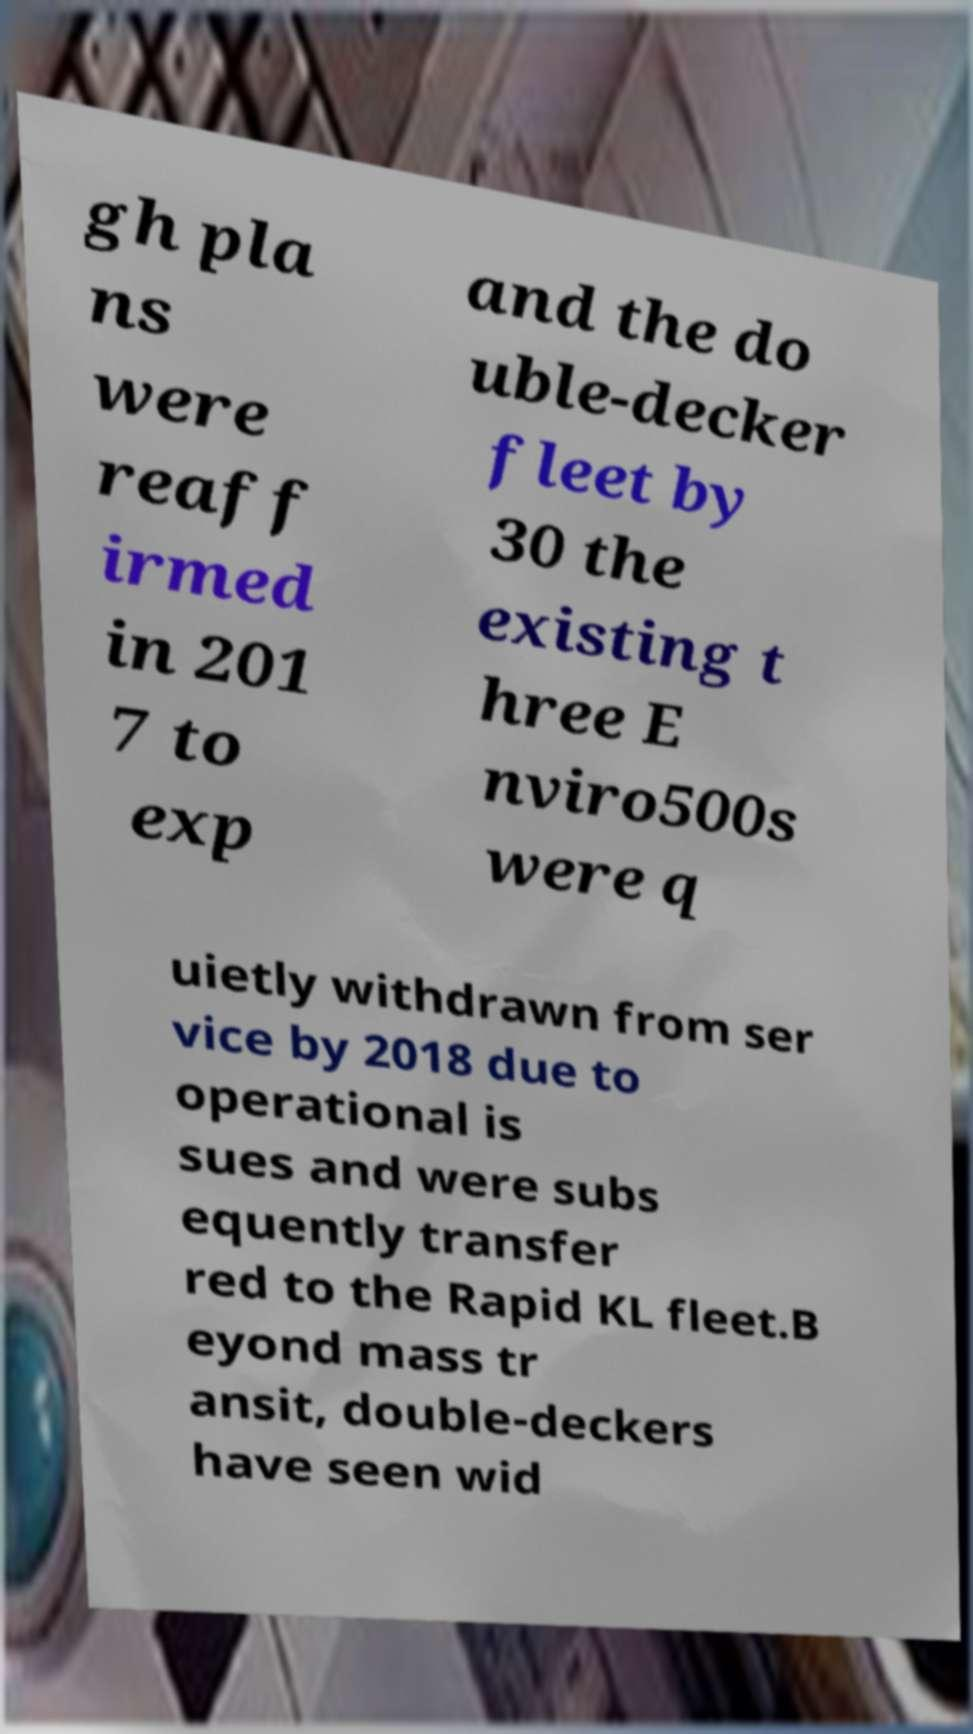I need the written content from this picture converted into text. Can you do that? gh pla ns were reaff irmed in 201 7 to exp and the do uble-decker fleet by 30 the existing t hree E nviro500s were q uietly withdrawn from ser vice by 2018 due to operational is sues and were subs equently transfer red to the Rapid KL fleet.B eyond mass tr ansit, double-deckers have seen wid 